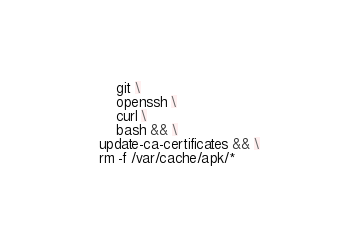Convert code to text. <code><loc_0><loc_0><loc_500><loc_500><_Dockerfile_>        git \
        openssh \
        curl \
        bash && \
    update-ca-certificates && \
    rm -f /var/cache/apk/*
</code> 